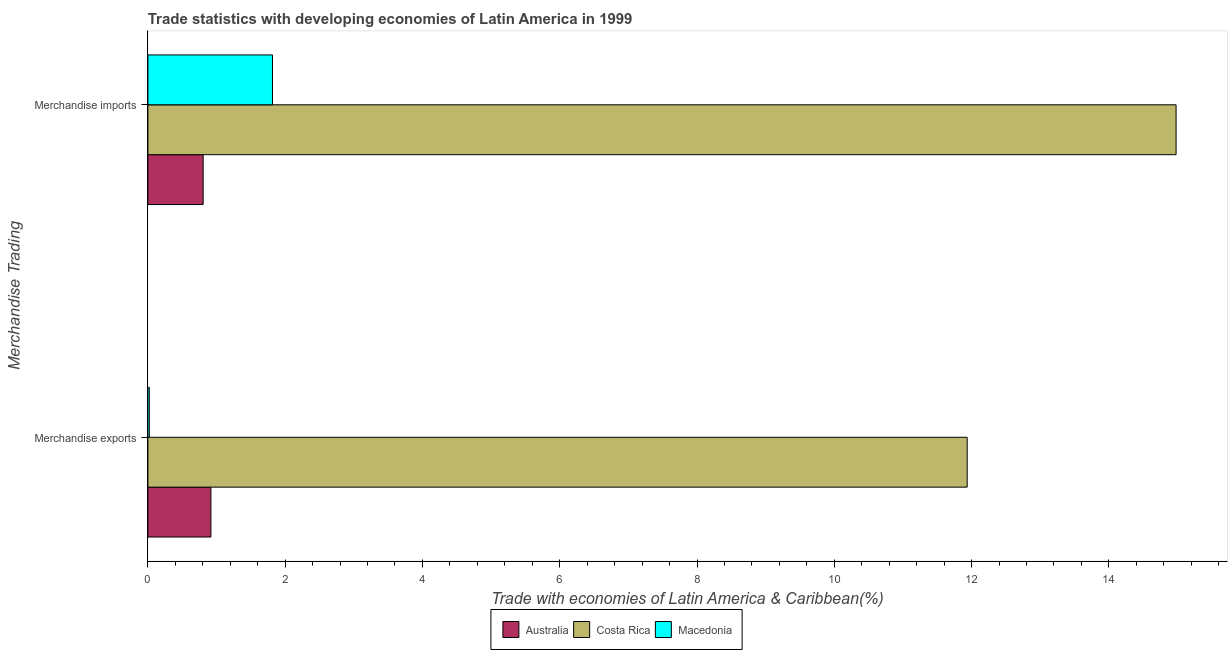How many groups of bars are there?
Your answer should be compact. 2. Are the number of bars on each tick of the Y-axis equal?
Your answer should be compact. Yes. What is the merchandise imports in Macedonia?
Ensure brevity in your answer.  1.82. Across all countries, what is the maximum merchandise exports?
Provide a succinct answer. 11.94. Across all countries, what is the minimum merchandise imports?
Your response must be concise. 0.81. In which country was the merchandise exports maximum?
Provide a short and direct response. Costa Rica. What is the total merchandise exports in the graph?
Provide a succinct answer. 12.88. What is the difference between the merchandise exports in Costa Rica and that in Australia?
Offer a terse response. 11.02. What is the difference between the merchandise exports in Costa Rica and the merchandise imports in Macedonia?
Ensure brevity in your answer.  10.12. What is the average merchandise imports per country?
Ensure brevity in your answer.  5.87. What is the difference between the merchandise exports and merchandise imports in Macedonia?
Make the answer very short. -1.79. In how many countries, is the merchandise imports greater than 12.4 %?
Ensure brevity in your answer.  1. What is the ratio of the merchandise exports in Australia to that in Costa Rica?
Your response must be concise. 0.08. Is the merchandise exports in Australia less than that in Costa Rica?
Offer a terse response. Yes. What does the 1st bar from the top in Merchandise exports represents?
Your response must be concise. Macedonia. What does the 1st bar from the bottom in Merchandise exports represents?
Your answer should be compact. Australia. How many countries are there in the graph?
Offer a terse response. 3. Are the values on the major ticks of X-axis written in scientific E-notation?
Keep it short and to the point. No. How many legend labels are there?
Ensure brevity in your answer.  3. How are the legend labels stacked?
Offer a terse response. Horizontal. What is the title of the graph?
Your response must be concise. Trade statistics with developing economies of Latin America in 1999. What is the label or title of the X-axis?
Your answer should be compact. Trade with economies of Latin America & Caribbean(%). What is the label or title of the Y-axis?
Offer a very short reply. Merchandise Trading. What is the Trade with economies of Latin America & Caribbean(%) of Australia in Merchandise exports?
Provide a short and direct response. 0.92. What is the Trade with economies of Latin America & Caribbean(%) in Costa Rica in Merchandise exports?
Give a very brief answer. 11.94. What is the Trade with economies of Latin America & Caribbean(%) of Macedonia in Merchandise exports?
Keep it short and to the point. 0.02. What is the Trade with economies of Latin America & Caribbean(%) of Australia in Merchandise imports?
Offer a very short reply. 0.81. What is the Trade with economies of Latin America & Caribbean(%) in Costa Rica in Merchandise imports?
Your answer should be very brief. 14.98. What is the Trade with economies of Latin America & Caribbean(%) in Macedonia in Merchandise imports?
Your answer should be compact. 1.82. Across all Merchandise Trading, what is the maximum Trade with economies of Latin America & Caribbean(%) of Australia?
Give a very brief answer. 0.92. Across all Merchandise Trading, what is the maximum Trade with economies of Latin America & Caribbean(%) in Costa Rica?
Make the answer very short. 14.98. Across all Merchandise Trading, what is the maximum Trade with economies of Latin America & Caribbean(%) in Macedonia?
Your answer should be very brief. 1.82. Across all Merchandise Trading, what is the minimum Trade with economies of Latin America & Caribbean(%) in Australia?
Your answer should be very brief. 0.81. Across all Merchandise Trading, what is the minimum Trade with economies of Latin America & Caribbean(%) in Costa Rica?
Make the answer very short. 11.94. Across all Merchandise Trading, what is the minimum Trade with economies of Latin America & Caribbean(%) of Macedonia?
Provide a short and direct response. 0.02. What is the total Trade with economies of Latin America & Caribbean(%) of Australia in the graph?
Keep it short and to the point. 1.72. What is the total Trade with economies of Latin America & Caribbean(%) in Costa Rica in the graph?
Provide a short and direct response. 26.92. What is the total Trade with economies of Latin America & Caribbean(%) in Macedonia in the graph?
Your answer should be very brief. 1.84. What is the difference between the Trade with economies of Latin America & Caribbean(%) of Australia in Merchandise exports and that in Merchandise imports?
Offer a very short reply. 0.11. What is the difference between the Trade with economies of Latin America & Caribbean(%) of Costa Rica in Merchandise exports and that in Merchandise imports?
Offer a terse response. -3.04. What is the difference between the Trade with economies of Latin America & Caribbean(%) of Macedonia in Merchandise exports and that in Merchandise imports?
Your answer should be very brief. -1.79. What is the difference between the Trade with economies of Latin America & Caribbean(%) of Australia in Merchandise exports and the Trade with economies of Latin America & Caribbean(%) of Costa Rica in Merchandise imports?
Make the answer very short. -14.06. What is the difference between the Trade with economies of Latin America & Caribbean(%) of Australia in Merchandise exports and the Trade with economies of Latin America & Caribbean(%) of Macedonia in Merchandise imports?
Ensure brevity in your answer.  -0.9. What is the difference between the Trade with economies of Latin America & Caribbean(%) of Costa Rica in Merchandise exports and the Trade with economies of Latin America & Caribbean(%) of Macedonia in Merchandise imports?
Give a very brief answer. 10.12. What is the average Trade with economies of Latin America & Caribbean(%) in Australia per Merchandise Trading?
Give a very brief answer. 0.86. What is the average Trade with economies of Latin America & Caribbean(%) in Costa Rica per Merchandise Trading?
Offer a very short reply. 13.46. What is the average Trade with economies of Latin America & Caribbean(%) in Macedonia per Merchandise Trading?
Your answer should be very brief. 0.92. What is the difference between the Trade with economies of Latin America & Caribbean(%) of Australia and Trade with economies of Latin America & Caribbean(%) of Costa Rica in Merchandise exports?
Make the answer very short. -11.02. What is the difference between the Trade with economies of Latin America & Caribbean(%) of Australia and Trade with economies of Latin America & Caribbean(%) of Macedonia in Merchandise exports?
Give a very brief answer. 0.9. What is the difference between the Trade with economies of Latin America & Caribbean(%) of Costa Rica and Trade with economies of Latin America & Caribbean(%) of Macedonia in Merchandise exports?
Your answer should be very brief. 11.92. What is the difference between the Trade with economies of Latin America & Caribbean(%) in Australia and Trade with economies of Latin America & Caribbean(%) in Costa Rica in Merchandise imports?
Offer a very short reply. -14.17. What is the difference between the Trade with economies of Latin America & Caribbean(%) of Australia and Trade with economies of Latin America & Caribbean(%) of Macedonia in Merchandise imports?
Offer a very short reply. -1.01. What is the difference between the Trade with economies of Latin America & Caribbean(%) in Costa Rica and Trade with economies of Latin America & Caribbean(%) in Macedonia in Merchandise imports?
Your response must be concise. 13.16. What is the ratio of the Trade with economies of Latin America & Caribbean(%) of Australia in Merchandise exports to that in Merchandise imports?
Offer a very short reply. 1.14. What is the ratio of the Trade with economies of Latin America & Caribbean(%) in Costa Rica in Merchandise exports to that in Merchandise imports?
Offer a terse response. 0.8. What is the ratio of the Trade with economies of Latin America & Caribbean(%) of Macedonia in Merchandise exports to that in Merchandise imports?
Provide a succinct answer. 0.01. What is the difference between the highest and the second highest Trade with economies of Latin America & Caribbean(%) of Australia?
Ensure brevity in your answer.  0.11. What is the difference between the highest and the second highest Trade with economies of Latin America & Caribbean(%) of Costa Rica?
Provide a short and direct response. 3.04. What is the difference between the highest and the second highest Trade with economies of Latin America & Caribbean(%) of Macedonia?
Make the answer very short. 1.79. What is the difference between the highest and the lowest Trade with economies of Latin America & Caribbean(%) of Australia?
Provide a succinct answer. 0.11. What is the difference between the highest and the lowest Trade with economies of Latin America & Caribbean(%) of Costa Rica?
Ensure brevity in your answer.  3.04. What is the difference between the highest and the lowest Trade with economies of Latin America & Caribbean(%) in Macedonia?
Your answer should be very brief. 1.79. 